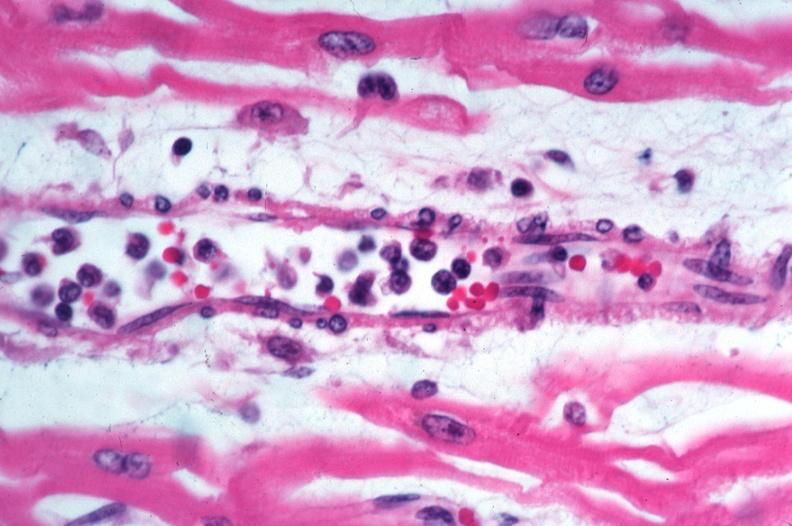where is this?
Answer the question using a single word or phrase. Skin 